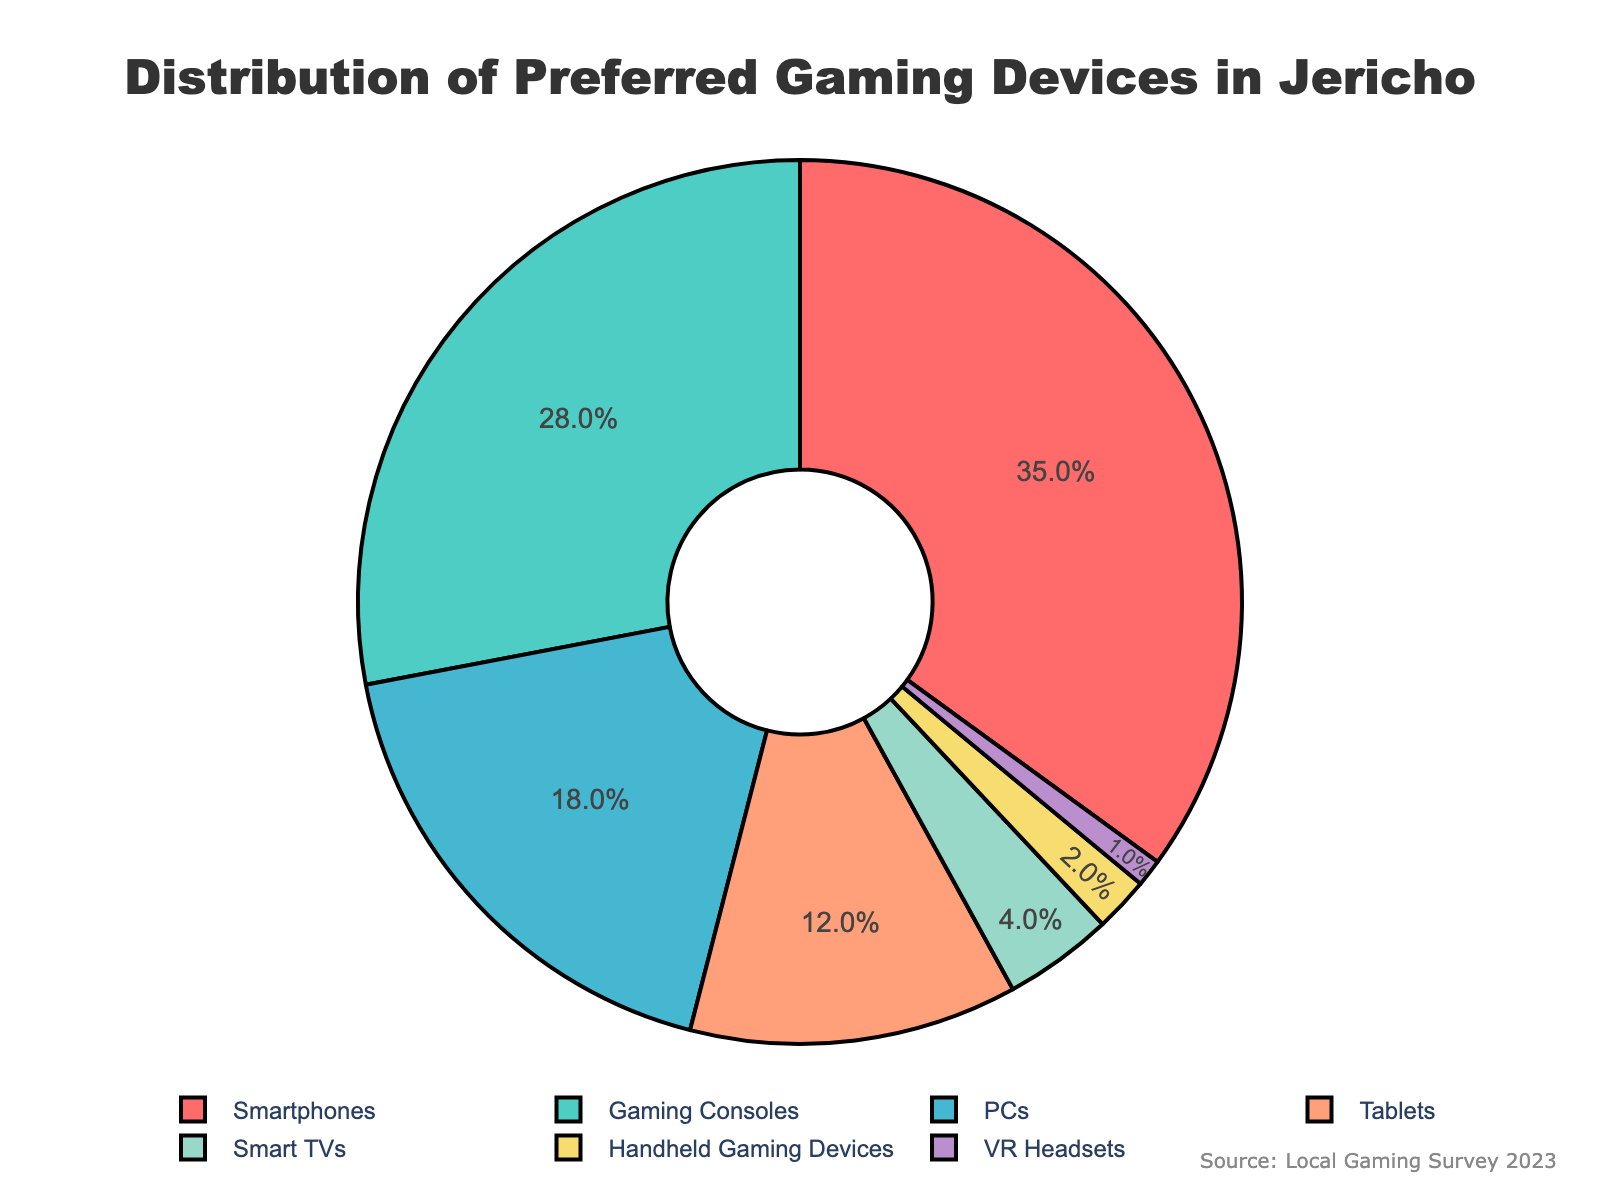What's the largest slice on the pie chart? The largest slice on the pie chart is labeled with "Smartphones" and has a percentage of 35%.
Answer: Smartphones Which device category ranks second in terms of preference among Jericho residents? The second largest slice on the pie chart is labeled with "Gaming Consoles" and has a percentage of 28%.
Answer: Gaming Consoles What is the total percentage of residents preferring handheld devices like Handheld Gaming Devices and VR Headsets combined? Add the percentage values of Handheld Gaming Devices (2%) and VR Headsets (1%): 2% + 1% = 3%.
Answer: 3% How much more popular are Smartphones compared to PCs among Jericho residents? Subtract the percentage of PCs (18%) from the percentage of Smartphones (35%): 35% - 18% = 17%.
Answer: 17% What percentage of residents prefer Tablets or Smart TVs? Add the percentage values of Tablets (12%) and Smart TVs (4%): 12% + 4% = 16%.
Answer: 16% Which device category has the smallest slice on the pie chart? The smallest slice on the pie chart is labeled with "VR Headsets" and has a percentage of 1%.
Answer: VR Headsets Are there more residents who prefer PCs or Tablets? The slice for PCs is larger at 18% compared to the slice for Tablets at 12%. Thus, more residents prefer PCs.
Answer: PCs What is the sum of the percentages for the top three preferred gaming devices? Add the percentages of Smartphones (35%), Gaming Consoles (28%), and PCs (18%): 35% + 28% + 18% = 81%.
Answer: 81% Compare the visual colors of the slices for Handheld Gaming Devices and Smart TVs. What colors are they? The slice for Handheld Gaming Devices is light purple and the slice for Smart TVs is yellow.
Answer: Light purple and yellow What is the difference in percentage between Smart TVs and Gaming Consoles preferences? Subtract the percentage of Smart TVs (4%) from the percentage of Gaming Consoles (28%): 28% - 4% = 24%.
Answer: 24% 